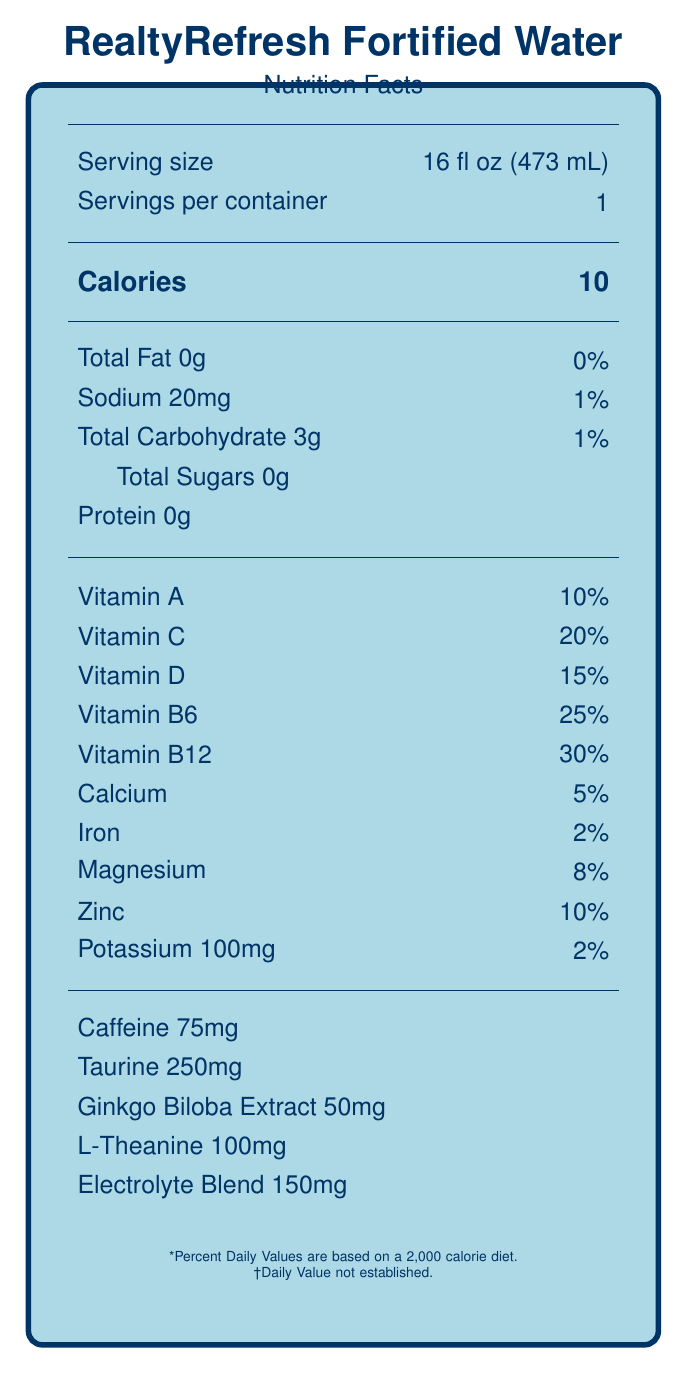what is the serving size of RealtyRefresh Fortified Water? The serving size is explicitly stated as "16 fl oz (473 mL)" in the document under the serving information section.
Answer: 16 fl oz (473 mL) how many calories are in one serving of RealtyRefresh Fortified Water? The calories count is clearly labeled as "10" in the document under the calories section.
Answer: 10 what percentage of Vitamin C does RealtyRefresh Fortified Water provide per serving? The document states that the drink provides 20% of the daily value of Vitamin C per serving.
Answer: 20% what is the amount of caffeine in RealtyRefresh Fortified Water? According to the additional ingredients section, the drink contains 75mg of caffeine per serving.
Answer: 75mg what is the purpose of RealtyRefresh Fortified Water as indicated in the product benefits section? The product benefits section lists “Supports mental clarity during long open houses, Helps maintain hydration during property tours, Boosts energy for late-night contract negotiations, Promotes focus for detailed paperwork completion, Aids in stress management during peak selling seasons.”
Answer: Supports mental clarity, hydration, energy, focus, and stress management how much protein is in RealtyRefresh Fortified Water? A. 0g B. 1g C. 10g The document specifies "Protein 0g" under the nutrients section.
Answer: A how much sodium is in RealtyRefresh Fortified Water? A. 20mg B. 50mg C. 100mg D. 200mg The Sodium content is listed as 20mg in the document under the nutrients section.
Answer: A how much potassium does RealtyRefresh Fortified Water contain? A. 50mg B. 100mg C. 150mg D. 200mg The document indicates that RealtyRefresh Fortified Water contains 100mg of potassium.
Answer: B are there any allergens present in RealtyRefresh Fortified Water? The allergen information states: "Produced in a facility that also processes soy and tree nuts."
Answer: Yes should RealtyRefresh Fortified Water be refrigerated after opening? The storage instructions specify that the bottle should be refrigerated after opening.
Answer: Yes summarize the main idea of the Nutrition Facts Label for RealtyRefresh Fortified Water. The document provides comprehensive nutritional details highlighting the benefits and contents of RealtyRefresh Fortified Water, emphasizing its suitability for real estate agents due to its mental and physical supportive properties. Key nutritional values, ingredients, benefits, storage instructions, and environmental considerations are all clearly outlined.
Answer: RealtyRefresh Fortified Water is a vitamin-fortified, low-calorie beverage designed to support mental clarity, hydration, energy, focus, and stress management for real estate agents working long hours. It contains various vitamins, minerals, and additional ingredients such as caffeine and taurine. Extensively detailed serving information, nutrient content, ingredient list, storage instructions, and allergen information are provided. The product is best consumed chilled between property showings or during client meetings, and the bottle should be recycled after use. how much Vitamin B12 does RealtyRefresh Fortified Water have? I need this for my dietary plan. The document states that the drink provides 30% of the daily value of Vitamin B12 per serving.
Answer: 30% does RealtyRefresh Fortified Water contain any B vitamins? RealtyRefresh Fortified Water contains Vitamin B6 (25%) and Vitamin B12 (30%).
Answer: Yes what is the electrolyte blend amount in RealtyRefresh Fortified Water? The document lists "Electrolyte Blend 150mg" under additional ingredients.
Answer: 150mg can RealtyRefresh Fortified Water help with stress management? One of the product benefits listed is "Aids in stress management during peak selling seasons."
Answer: Yes who manufactures RealtyRefresh Fortified Water? The manufacturer information states that RealtyRefresh Fortified Water is produced by VigorVitals Beverages, Inc.
Answer: VigorVitals Beverages, Inc. is RealtyRefresh Fortified Water suitable for someone with nut allergies? The allergen information states it is produced in a facility that processes soy and tree nuts, but it does not explicitly state if any nuts are present in the product itself.
Answer: Cannot be determined 